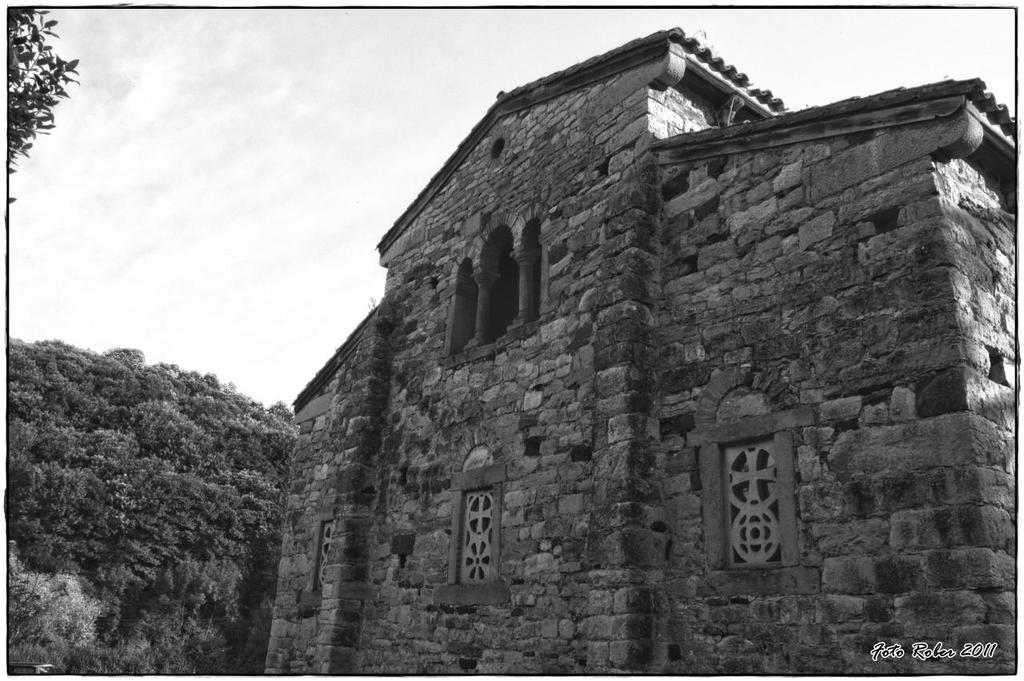What type of structure is visible in the image? There is a building in the image. What can be seen in the background of the image? There are trees and the sky visible in the background of the image. What is the color scheme of the image? The image is in black and white. How many pies are being held by the toes in the image? There are no pies or toes present in the image. What color is the crayon used to draw the building in the image? The image is in black and white, so there is no crayon used to draw the building. 